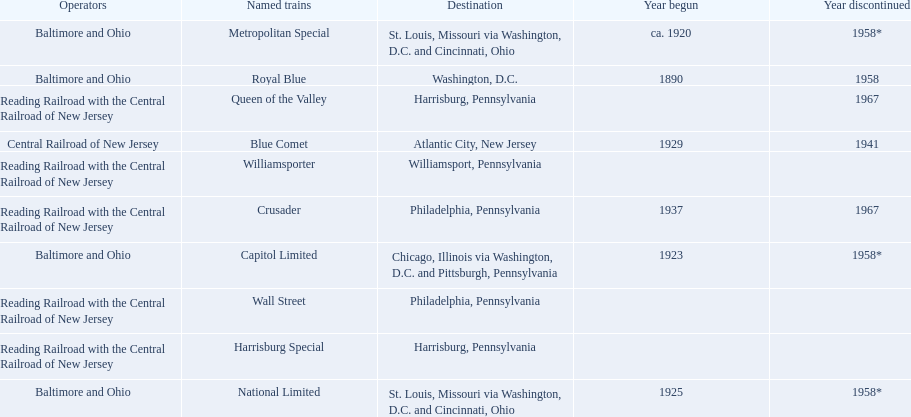What destinations are listed from the central railroad of new jersey terminal? Chicago, Illinois via Washington, D.C. and Pittsburgh, Pennsylvania, St. Louis, Missouri via Washington, D.C. and Cincinnati, Ohio, St. Louis, Missouri via Washington, D.C. and Cincinnati, Ohio, Washington, D.C., Atlantic City, New Jersey, Philadelphia, Pennsylvania, Harrisburg, Pennsylvania, Harrisburg, Pennsylvania, Philadelphia, Pennsylvania, Williamsport, Pennsylvania. Which of these destinations is listed first? Chicago, Illinois via Washington, D.C. and Pittsburgh, Pennsylvania. 